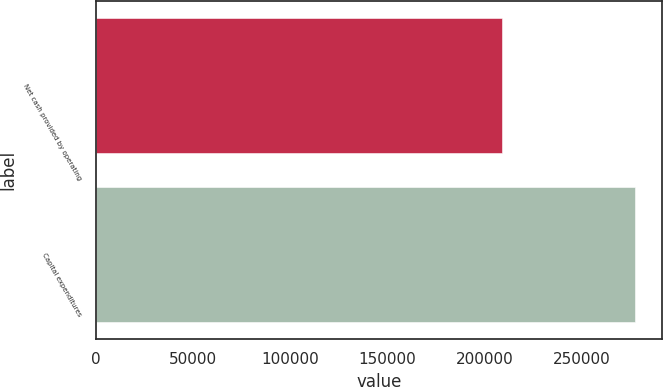Convert chart. <chart><loc_0><loc_0><loc_500><loc_500><bar_chart><fcel>Net cash provided by operating<fcel>Capital expenditures<nl><fcel>208932<fcel>277262<nl></chart> 